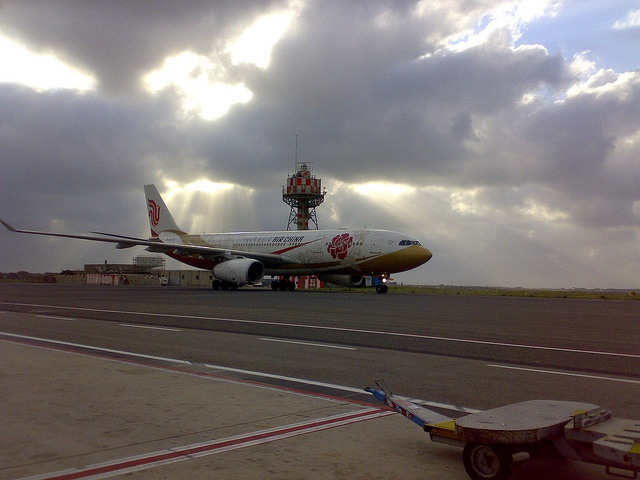Describe the objects in this image and their specific colors. I can see a airplane in gray, black, and maroon tones in this image. 